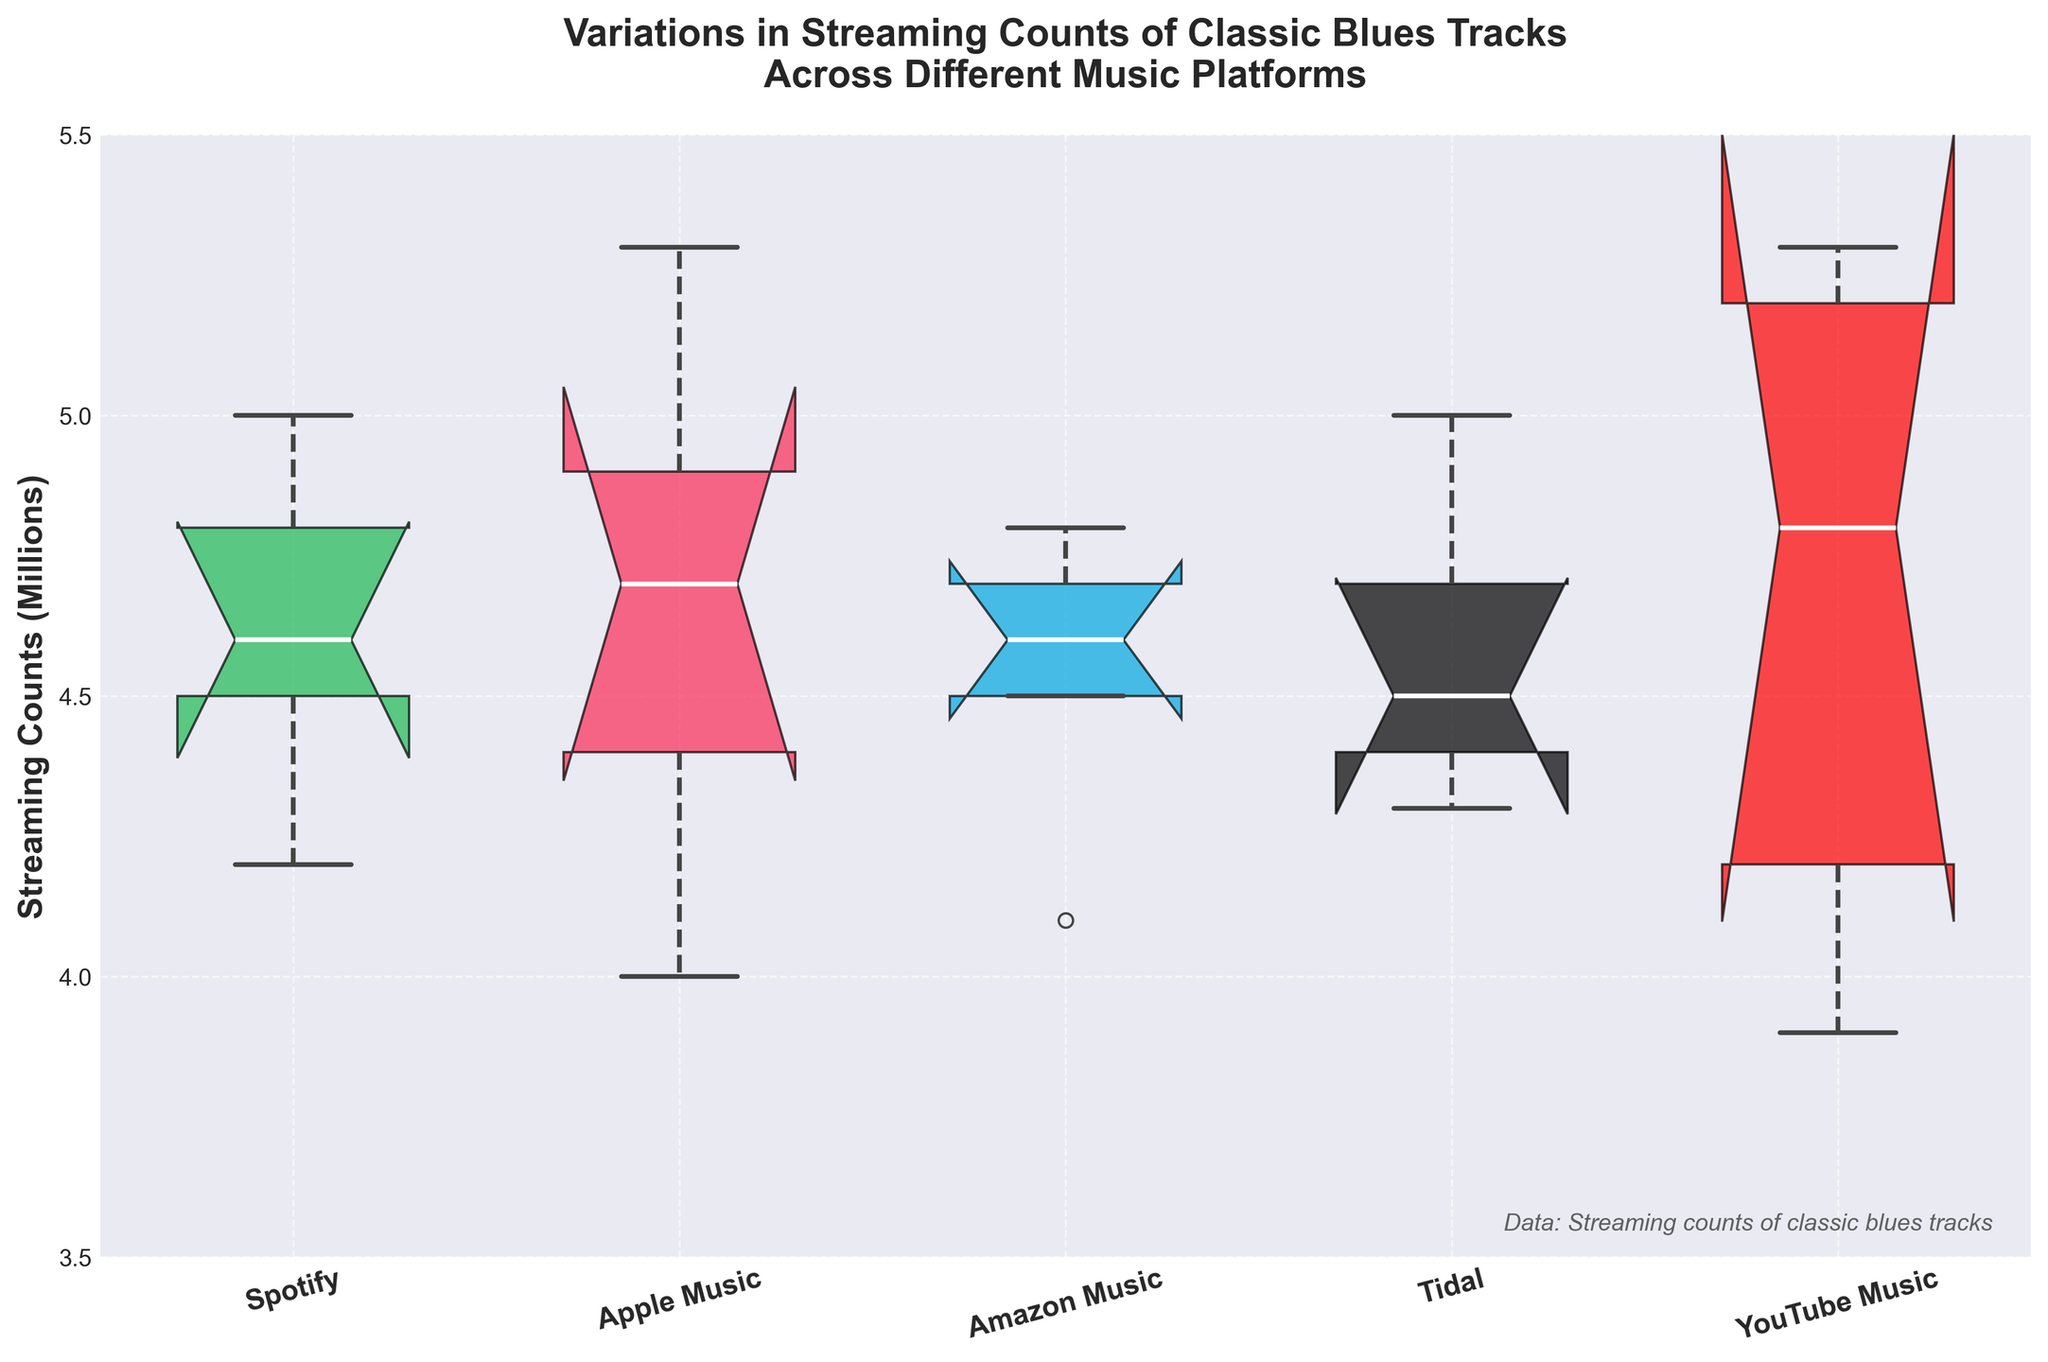What is the title of the figure? The title is typically displayed at the top of the plot. It provides an overview of what the data represents. By looking at the top of the plot, we can see the following: "Variations in Streaming Counts of Classic Blues Tracks Across Different Music Platforms".
Answer: Variations in Streaming Counts of Classic Blues Tracks Across Different Music Platforms Which music platform has the highest streaming count for the track "The Thrill Is Gone"? To find the highest streaming count for "The Thrill Is Gone," we look at the notched box plot and identify the maximum values for the track across the different platforms. The maximum count occurs under the box representing YouTube Music.
Answer: YouTube Music How many distinct music platforms are compared in the plot? Each distinct color in the notched box plot corresponds to a different music platform. By counting the number of unique colors or the number of labels on the x-axis, we can determine the number of platforms.
Answer: 5 Which music platform has the lowest median streaming count? The median of each platform can be identified by finding the central line inside each box. The lowest median is identified by comparing the heights of these lines. The platform with the lowest median is YouTube Music, as its median line is lower compared to others.
Answer: YouTube Music What is the range of streaming counts shown on the y-axis? The range can be identified by looking at the values on the y-axis. The minimum value begins at 3.5 million, and the maximum value reaches up to 5.5 million.
Answer: 3.5 million to 5.5 million Which music platforms have overlapping notches indicating no significant difference in medians? Overlapping notches suggest there is no significant difference between the medians of the platforms. By looking for where notches overlap, we can see that Amazon Music and Tidal have overlapping notches.
Answer: Amazon Music and Tidal For which track do Spotify and Apple Music have the highest median streaming counts? We first identify the tracks and then compare the medians for each platform. The highest median count for both Spotify and Apple Music can be verified by looking at the central lines within the boxes for each track on these platforms. Apple Music and Spotify both show the highest median for "Muddy Waters - Hoochie Coochie Man".
Answer: Muddy Waters - Hoochie Coochie Man Does the box plot for Tidal show any outliers, and if so, what does this signify? Outliers in a box plot are represented by their fliers, outside the whiskers. By observing Tidal's box plot, no outliers are seen. Hence, Tidal does not show any unusual streaming counts beyond its whisker range.
Answer: No How does the interquartile range (IQR) for Apple Music compare to that of Amazon Music? The interquartile range (IQR) is the difference between the upper quartile (Q3) and the lower quartile (Q1). By looking at the box width, we compare the height of each box (excluding the whiskers). Apple Music has a wider box, indicating a larger IQR compared to Amazon Music.
Answer: Apple Music has a larger IQR Which platform has the widest variation in streaming counts? The platform with the widest box has the widest variation in streaming counts, evidenced by the length of the box along the y-axis. After examining all platforms, Apple Music shows the widest variation.
Answer: Apple Music 